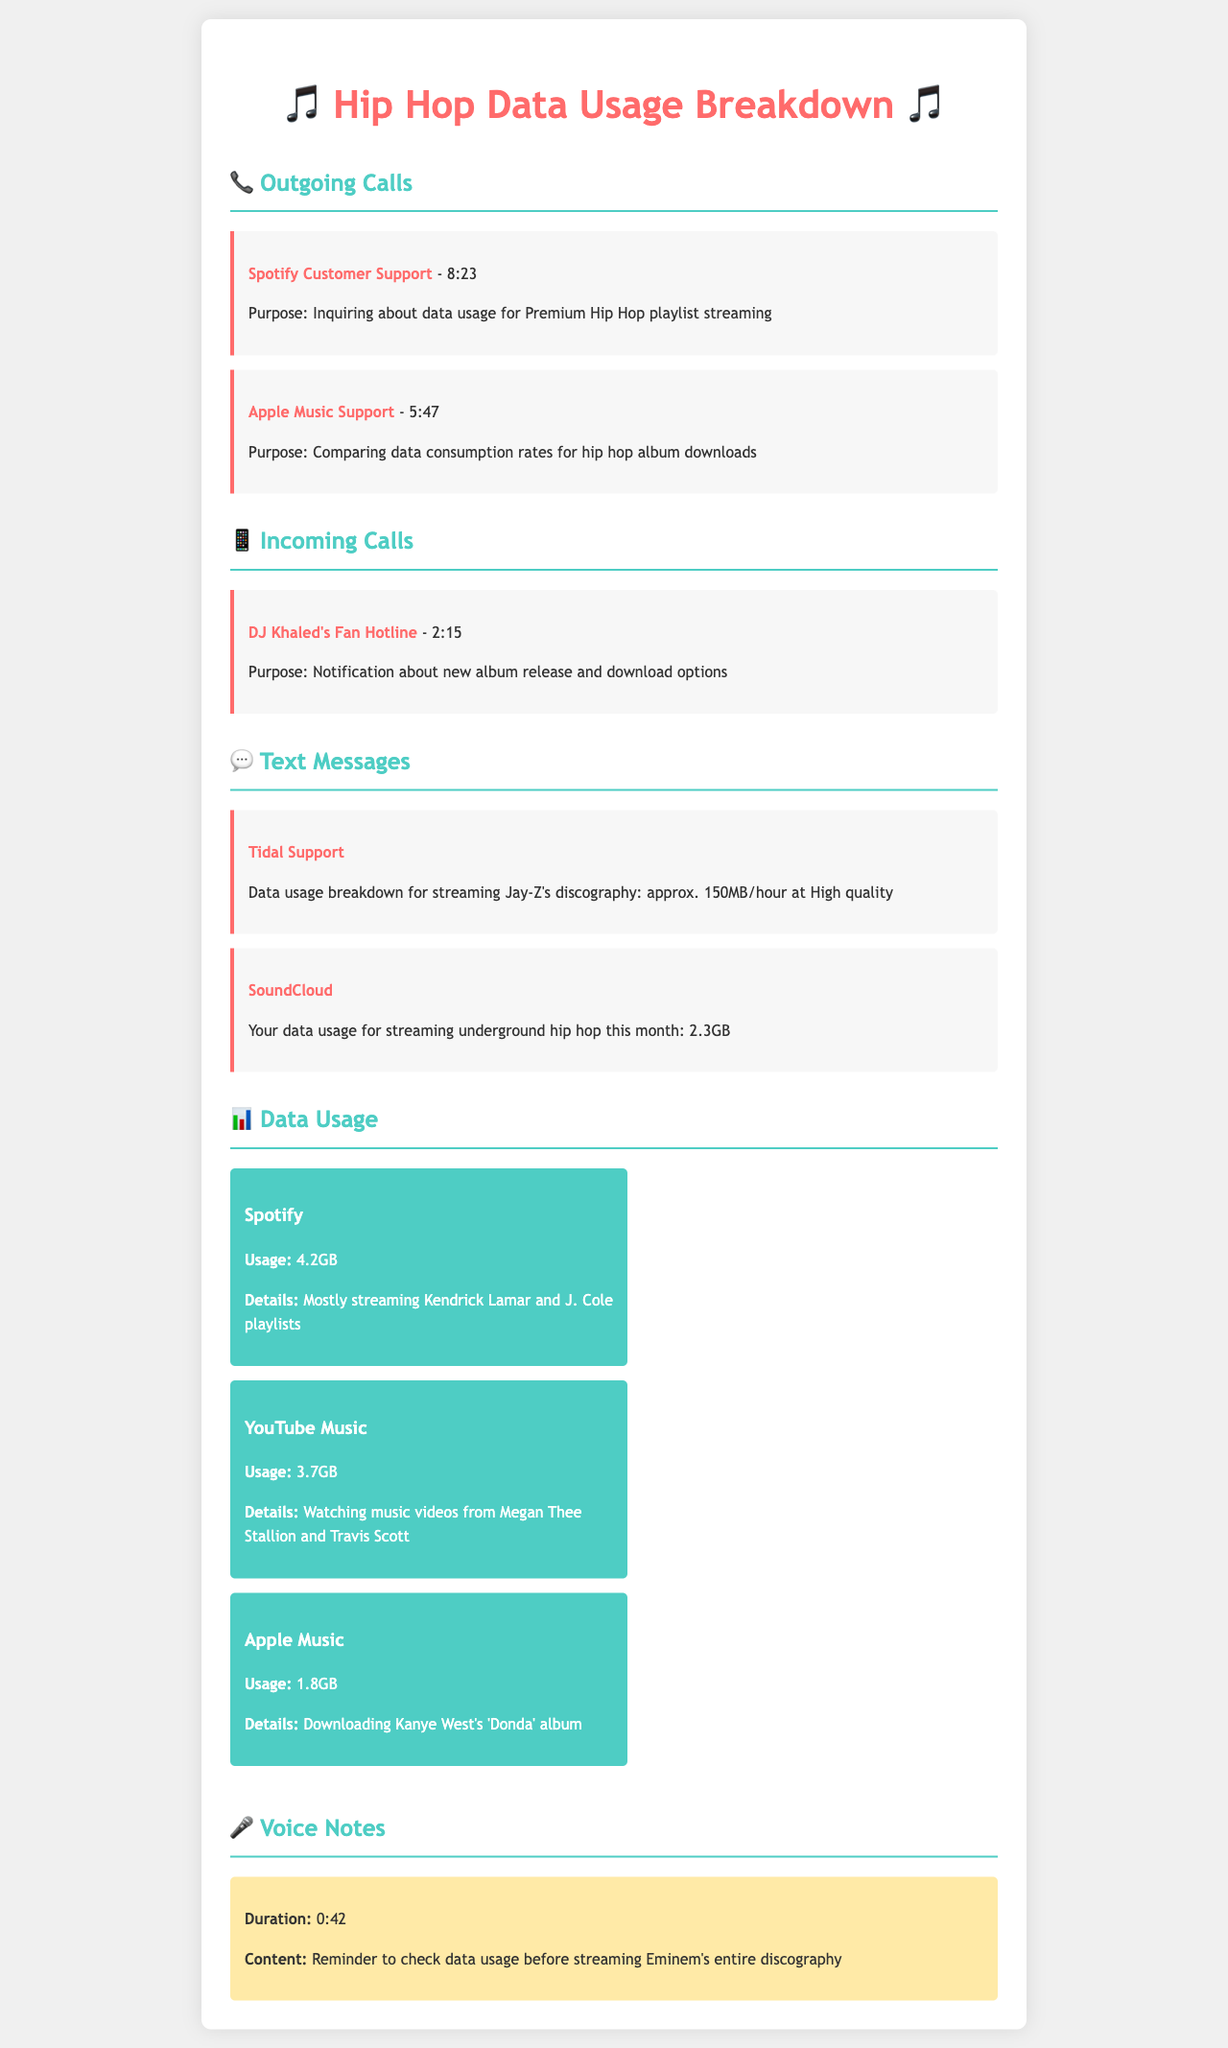What was the duration of the call to Spotify Customer Support? The document cites that the call lasted 8 minutes and 23 seconds.
Answer: 8:23 How much data was used for streaming underground hip hop on SoundCloud this month? The document indicates that the data usage for SoundCloud is 2.3GB for the month.
Answer: 2.3GB What is the total data usage recorded for Spotify? The total data usage reported for Spotify is 4.2GB.
Answer: 4.2GB Which artist's album was downloaded on Apple Music? The document specifies that Kanye West's 'Donda' album was downloaded.
Answer: Kanye West's 'Donda' What is the average data usage for streaming Jay-Z's discography according to Tidal Support? The text says the average data usage for streaming his discography is approximately 150MB per hour at high quality.
Answer: 150MB/hour How many minutes were spent on the call with Apple Music Support? The document states that the call duration was 5 minutes and 47 seconds.
Answer: 5:47 What is the total data used across all platforms mentioned in the document? To find the total data usage, sum the individual platform usages: 4.2GB + 3.7GB + 1.8GB = 9.7GB.
Answer: 9.7GB Who called with a notification about a new album release? The document identifies that DJ Khaled's Fan Hotline was the source of the notification.
Answer: DJ Khaled's Fan Hotline What is the content of the voice note? The voice note reminds the user to check data usage before streaming Eminem's entire discography.
Answer: Reminder to check data usage before streaming Eminem's entire discography 